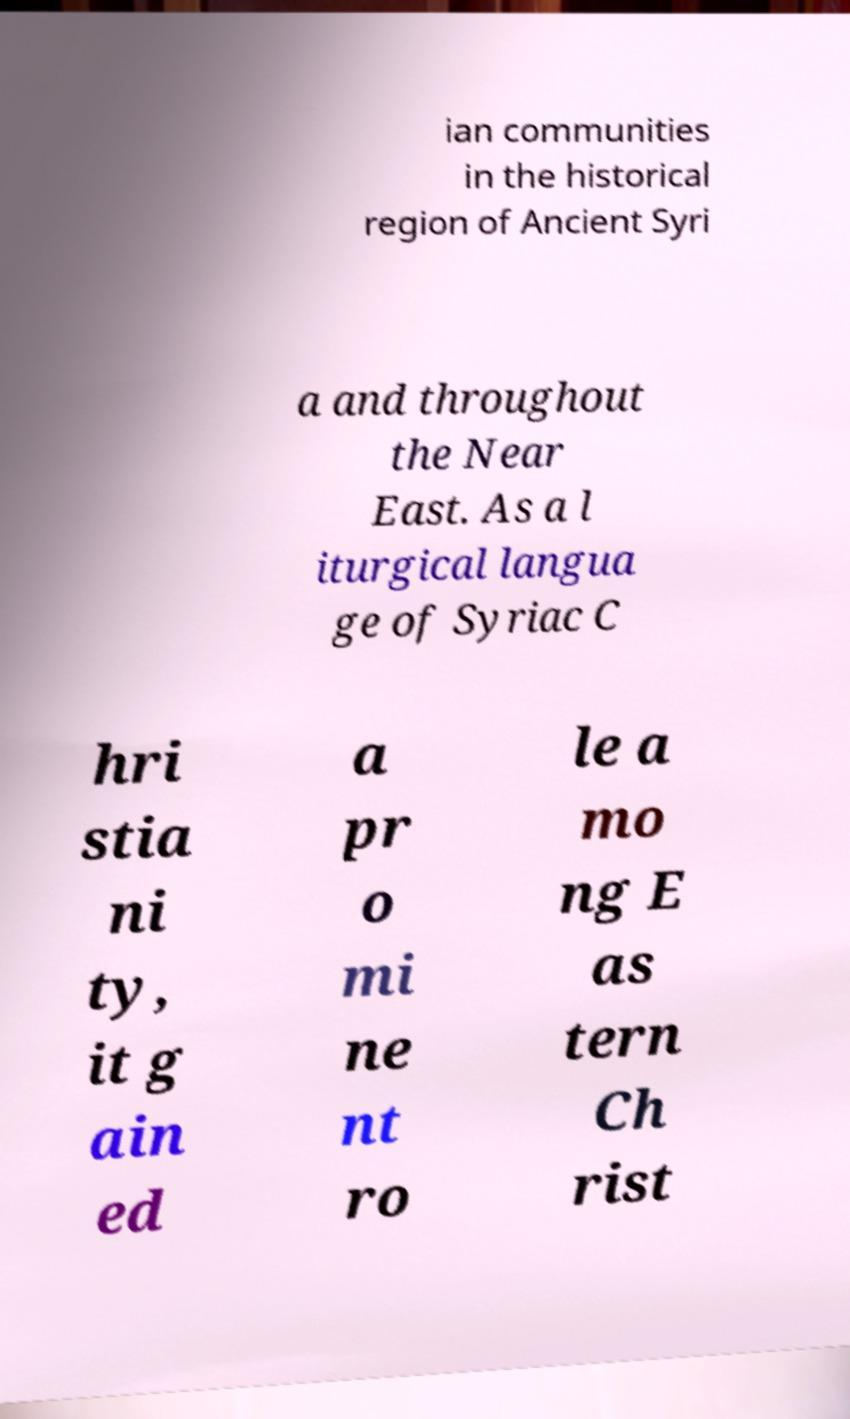For documentation purposes, I need the text within this image transcribed. Could you provide that? ian communities in the historical region of Ancient Syri a and throughout the Near East. As a l iturgical langua ge of Syriac C hri stia ni ty, it g ain ed a pr o mi ne nt ro le a mo ng E as tern Ch rist 